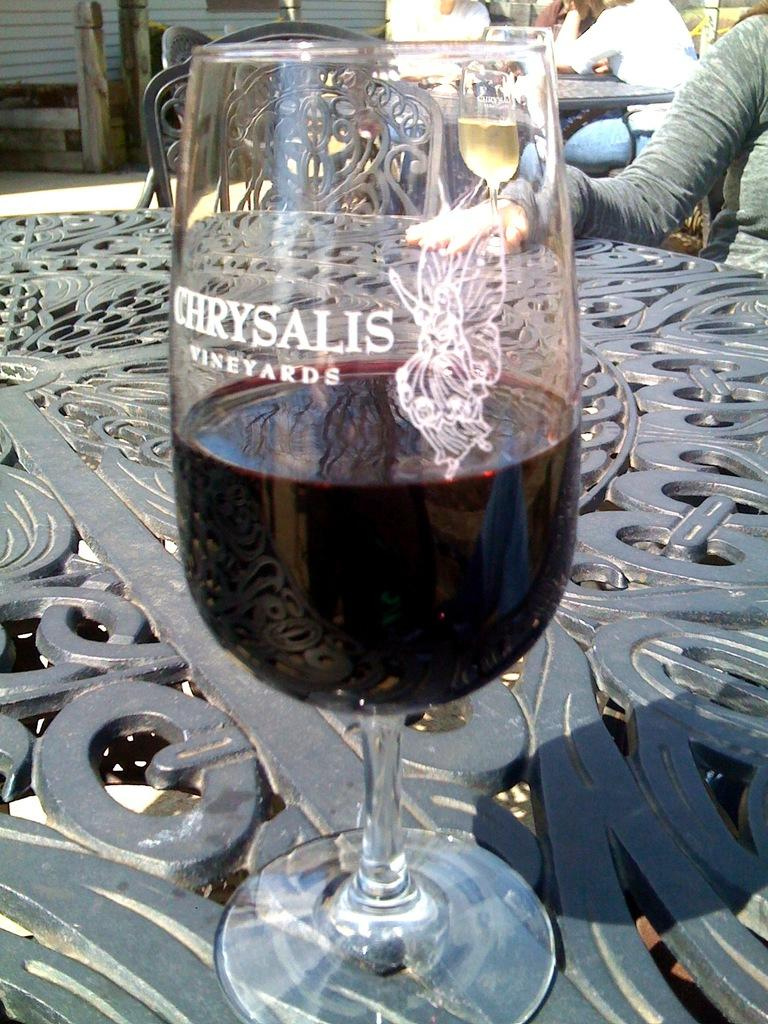What type of furniture is present in the image? There are tables and chairs in the image. What can be found on the tables in the image? There are glasses with liquids on the tables in the image. Are there any people in the image? Yes, there are people in the image. What other objects can be seen in the image? There are other objects in the image, but their specific details are not mentioned in the provided facts. What type of doctor is attending to the patients in the image? There is no doctor present in the image; it features tables, chairs, glasses with liquids, and people. Can you tell me how many lamps are visible in the image? There is no lamp present in the image; it features tables, chairs, glasses with liquids, and people. 